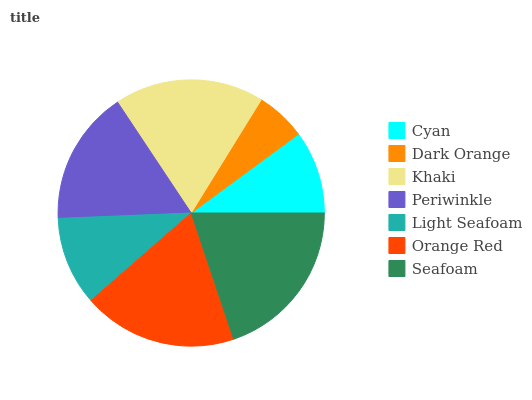Is Dark Orange the minimum?
Answer yes or no. Yes. Is Seafoam the maximum?
Answer yes or no. Yes. Is Khaki the minimum?
Answer yes or no. No. Is Khaki the maximum?
Answer yes or no. No. Is Khaki greater than Dark Orange?
Answer yes or no. Yes. Is Dark Orange less than Khaki?
Answer yes or no. Yes. Is Dark Orange greater than Khaki?
Answer yes or no. No. Is Khaki less than Dark Orange?
Answer yes or no. No. Is Periwinkle the high median?
Answer yes or no. Yes. Is Periwinkle the low median?
Answer yes or no. Yes. Is Dark Orange the high median?
Answer yes or no. No. Is Cyan the low median?
Answer yes or no. No. 